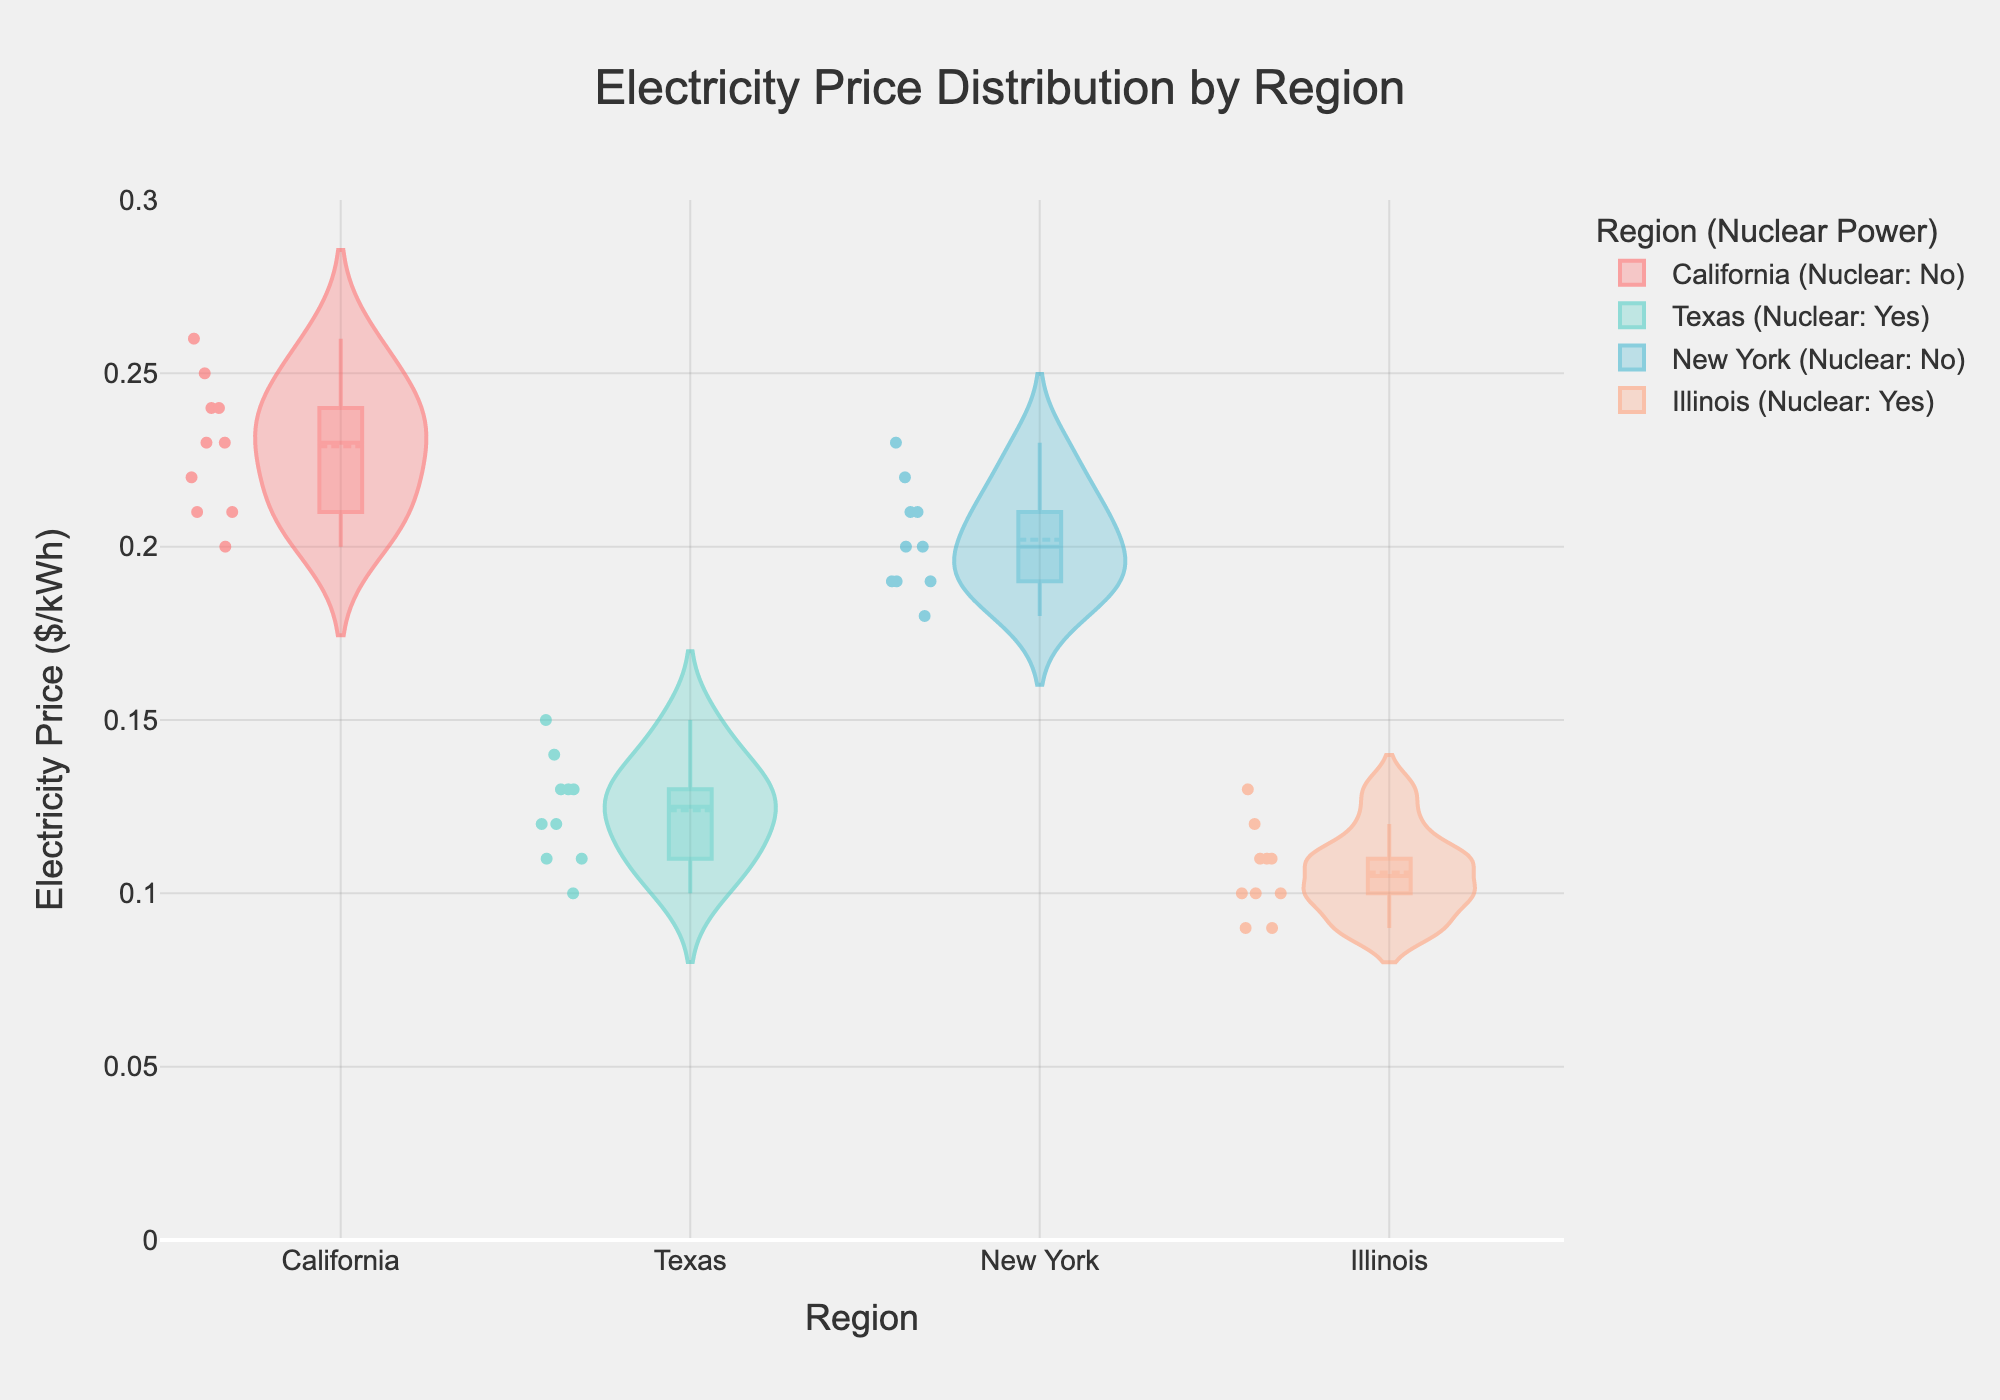Which region has the highest average electricity price? By examining the box plot, we can see that each box's mean line signifies the average price. California's mean line is higher than those of Texas, New York, and Illinois.
Answer: California Which region has the lowest variability in electricity prices? The box plot with the narrowest spread would indicate the lowest variability. Illinois shows the smallest spread between the box edges.
Answer: Illinois Do regions with nuclear power generally have lower electricity prices? Comparing Texas and Illinois (both with nuclear power) to California and New York (without nuclear power) shows that Texas and Illinois have lower mean lines, indicating lower prices.
Answer: Yes What is the range of electricity prices in Texas? The range can be determined by subtracting the minimum value (lowest whisker) from the maximum value (highest whisker). For Texas, it ranges from approximately $0.10 to $0.15 per kWh.
Answer: 0.10 to 0.15 $/kWh How do the mean electricity prices in New York and Texas compare? The mean prices are indicated by the dashed lines in the box plots. New York's mean line is at a higher price level compared to Texas' mean line.
Answer: New York is higher Which region displays the most outliers in electricity prices? Outliers are the individual points outside the whiskers of the box plots. New York shows more outlying data points compared to other regions.
Answer: New York How does the price distribution in California compare to Illinois? California has a higher and wider spread distribution indicated by both the heights and widths of its box plot compared to the compact and lower prices in Illinois.
Answer: Higher and wider What is the median electricity price in Illinois? The median is indicated by the line within the box. Illinois' median line sits around $0.11 per kWh.
Answer: 0.11 $/kWh Are there any regions where the mean and median electricity prices are approximately the same? By checking the alignment of the box's mean (dashed line) and median (solid line), we see that in Texas and Illinois the mean and median lines are very close.
Answer: Texas and Illinois 